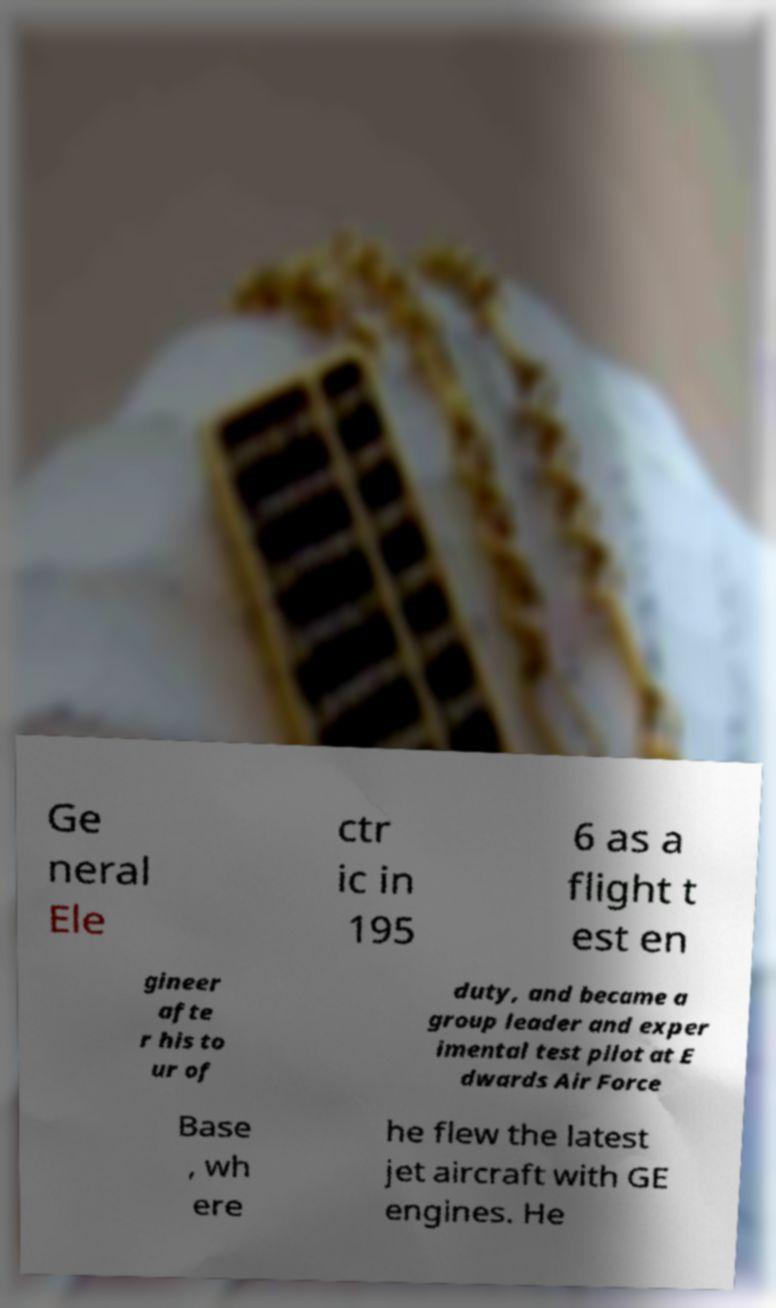Please read and relay the text visible in this image. What does it say? Ge neral Ele ctr ic in 195 6 as a flight t est en gineer afte r his to ur of duty, and became a group leader and exper imental test pilot at E dwards Air Force Base , wh ere he flew the latest jet aircraft with GE engines. He 